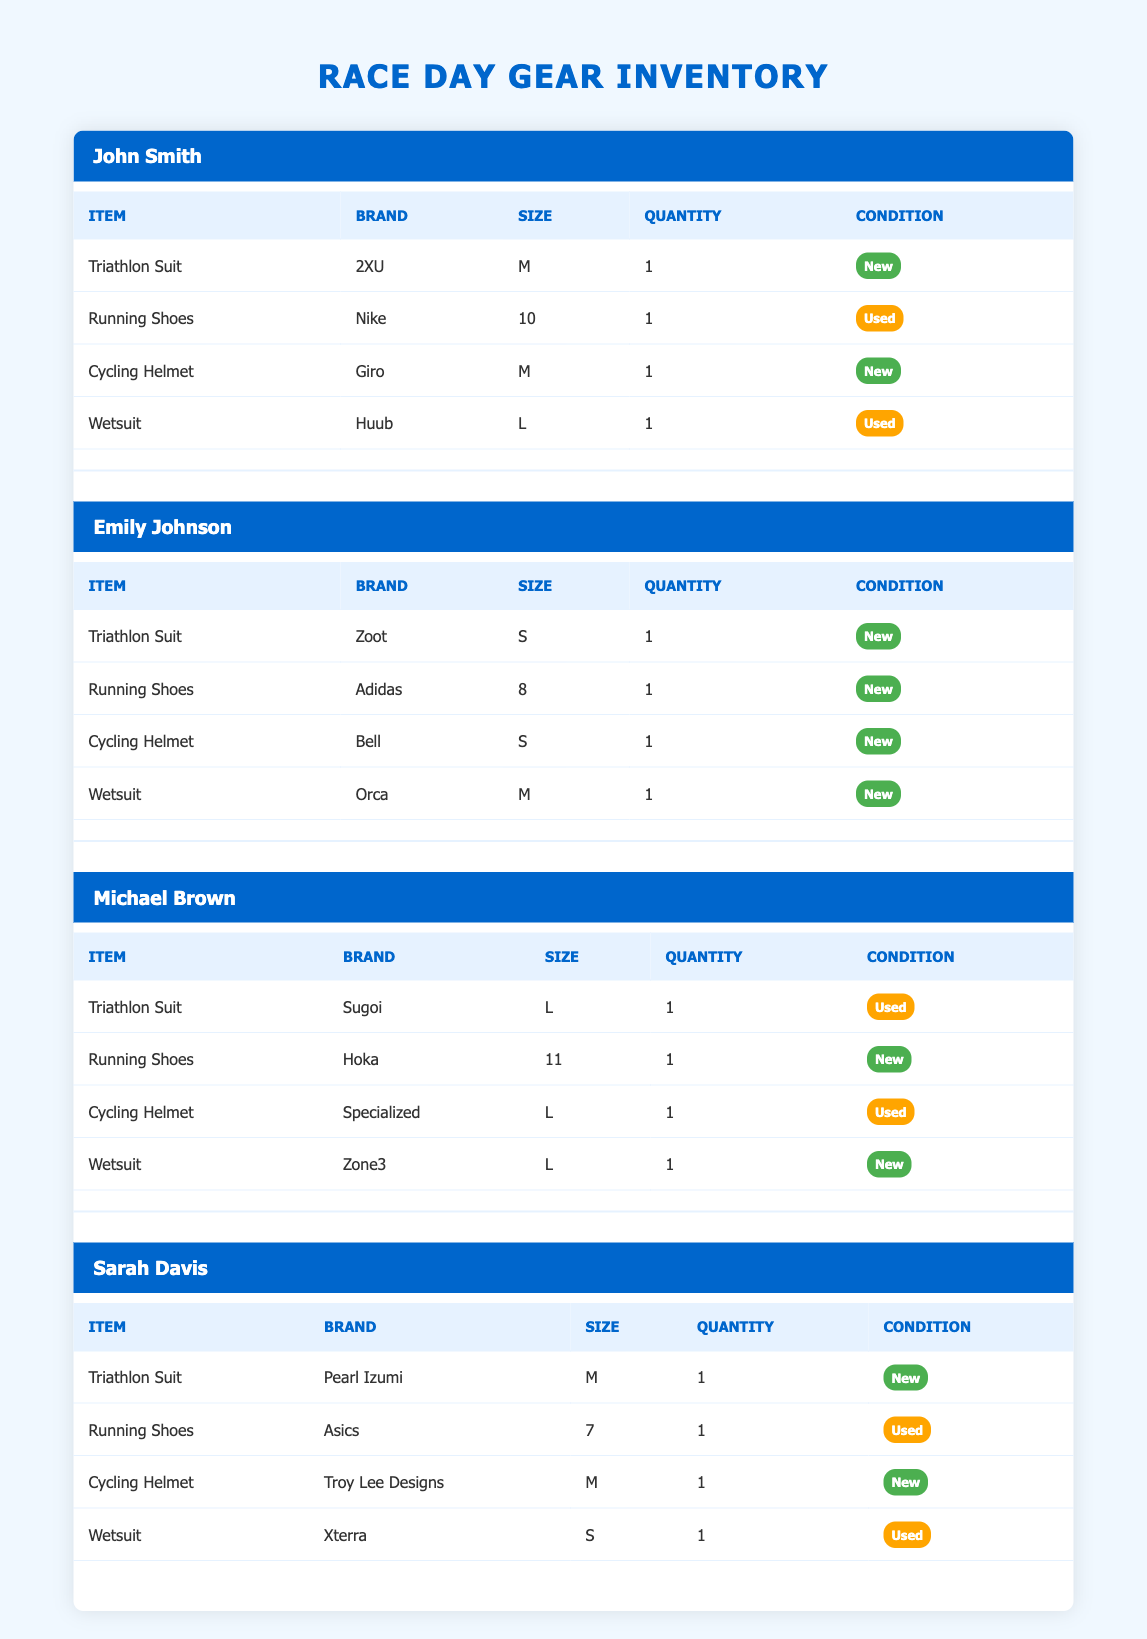What is the total number of items in John Smith's inventory? John Smith has 4 items listed in his inventory. These are the Triathlon Suit, Running Shoes, Cycling Helmet, and Wetsuit. The condition and quantity are not relevant for counting items.
Answer: 4 Which participant has the most items in new condition? Both Emily Johnson and Michael Brown have all their items in new condition, totaling 4 items each. Other participants have mixed conditions.
Answer: Emily Johnson and Michael Brown What size wetsuit does Sarah Davis have? Sarah Davis has a wetsuit that is size S, as noted in her inventory section.
Answer: S How many participants have a Triathlon Suit in new condition? From the table, there are 3 participants (John Smith, Emily Johnson, and Sarah Davis) who have a Triathlon Suit in new condition. Michael Brown's suit is used.
Answer: 3 Does Michael Brown have any used items? Yes, Michael Brown has two items listed as used: the Triathlon Suit and the Cycling Helmet.
Answer: Yes What is the average size of the Cycling Helmets among all participants? The sizes of the Cycling Helmets are M, S, L, and M for John, Emily, Michael, and Sarah respectively. Converting sizes, we can visualize S < M < L, placing them as 1 (S), 2 (M), 3 (L). The total is 1 + 2 + 3 + 2 = 8, divided by 4 gives an average size of 2 (M).
Answer: M How many participants have Running Shoes that are new? Out of the four participants, three (Emily Johnson, Michael Brown) have new Running Shoes. John Smith's are used, while Sarah Davis's are also used.
Answer: 3 Which participant has a cycling helmet but not a wetsuit? John Smith has a Cycling Helmet but his Wetsuit is used. The other participants either have both or new wetsuits.
Answer: John Smith What is the total number of used items across all participants? Checking each participant, John Smith has 2 used items (Running Shoes, Wetsuit), Michael Brown has 2 (Triathlon Suit, Cycling Helmet), Sarah Davis has 2 (Running Shoes, Wetsuit), totaling 6 used items among all participants.
Answer: 6 